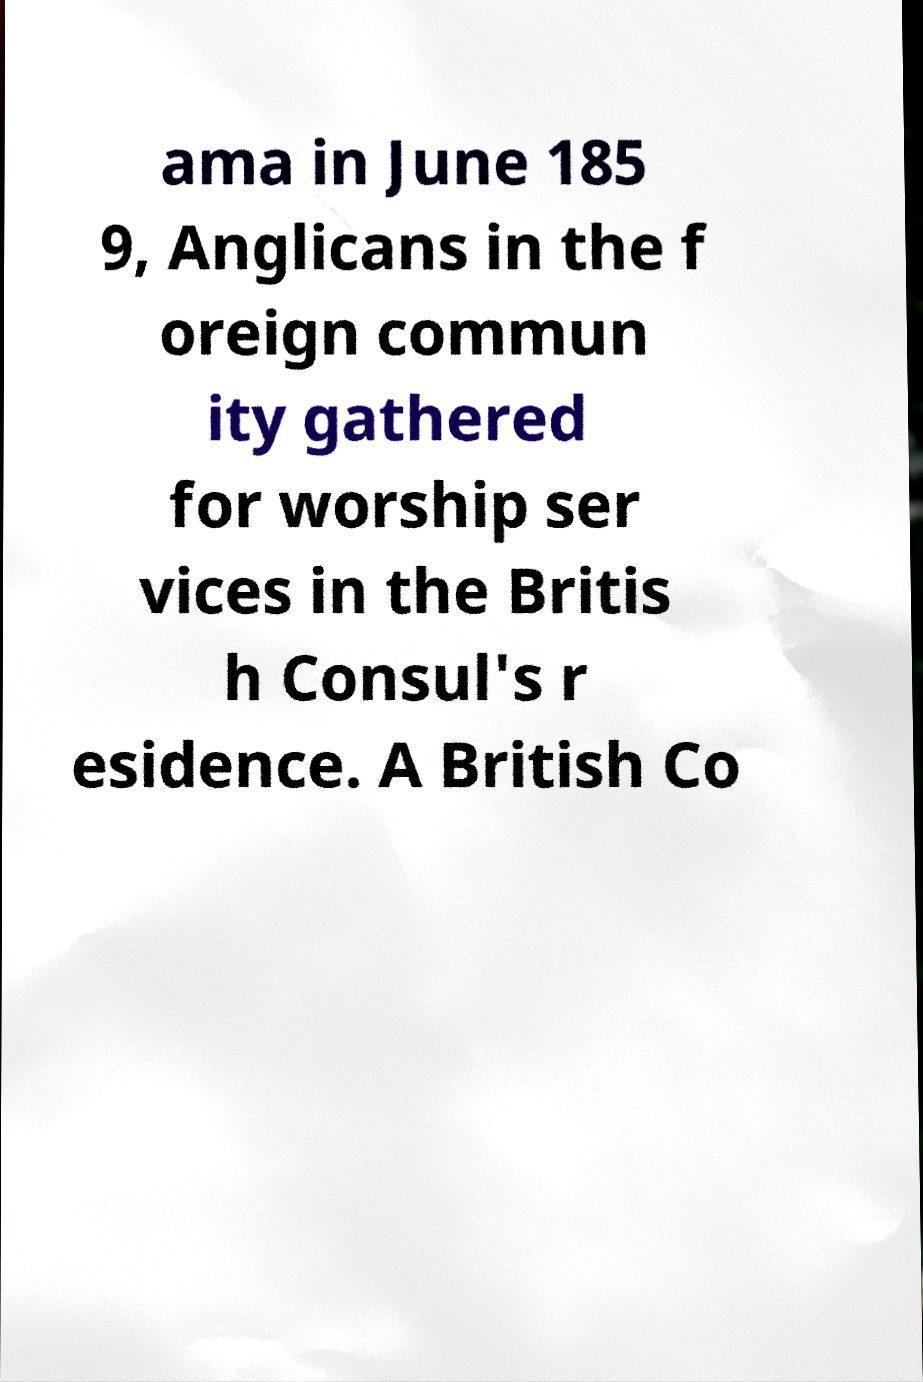There's text embedded in this image that I need extracted. Can you transcribe it verbatim? ama in June 185 9, Anglicans in the f oreign commun ity gathered for worship ser vices in the Britis h Consul's r esidence. A British Co 